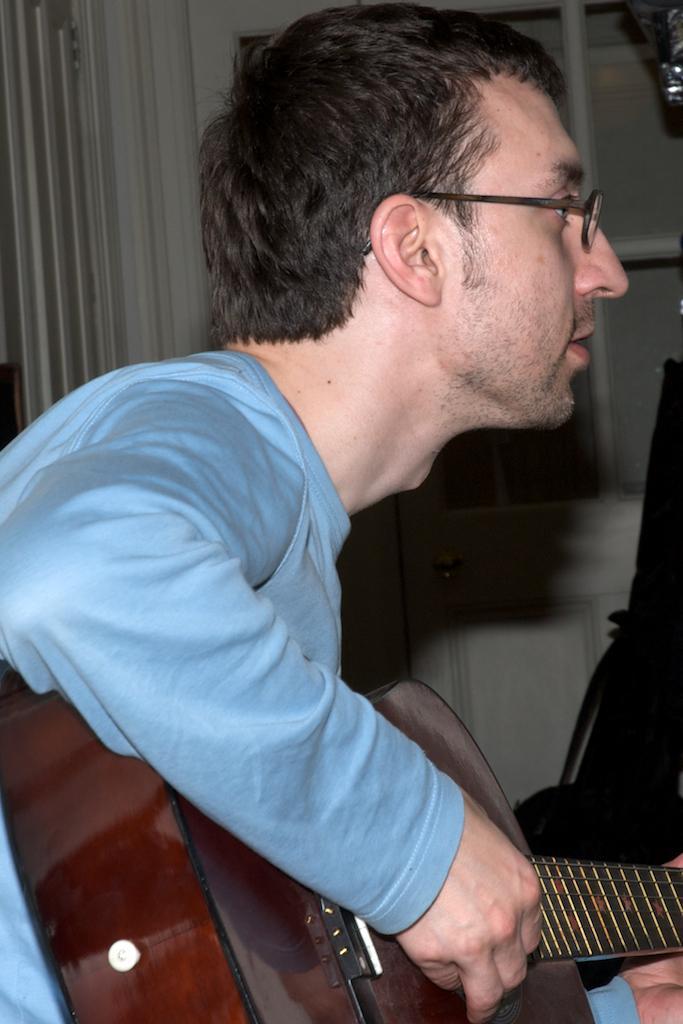Describe this image in one or two sentences. In the image we can see there is a person who is holding guitar in his hand. 